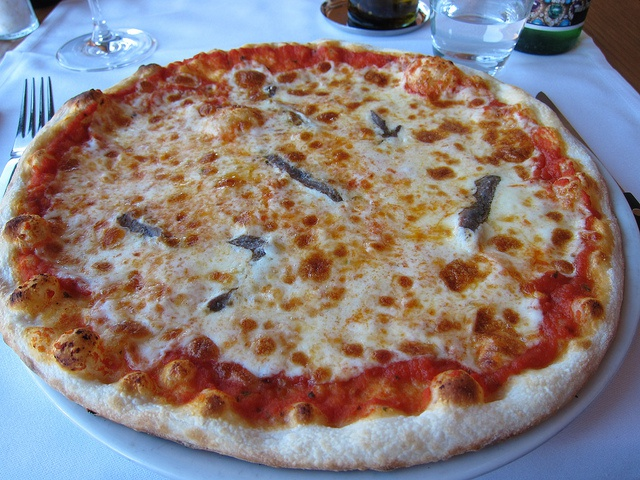Describe the objects in this image and their specific colors. I can see dining table in darkgray, lightblue, maroon, gray, and brown tones, pizza in darkgray, maroon, gray, and brown tones, cup in darkgray, lightblue, and gray tones, wine glass in darkgray, lightblue, and white tones, and bottle in darkgray, black, gray, navy, and darkgreen tones in this image. 